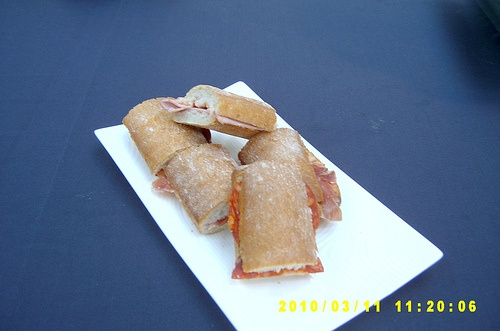Describe the objects in this image and their specific colors. I can see sandwich in darkblue, tan, and salmon tones, sandwich in darkblue, darkgray, tan, and gray tones, sandwich in darkblue, lightgray, and tan tones, sandwich in darkblue, tan, gray, and darkgray tones, and sandwich in darkblue and tan tones in this image. 